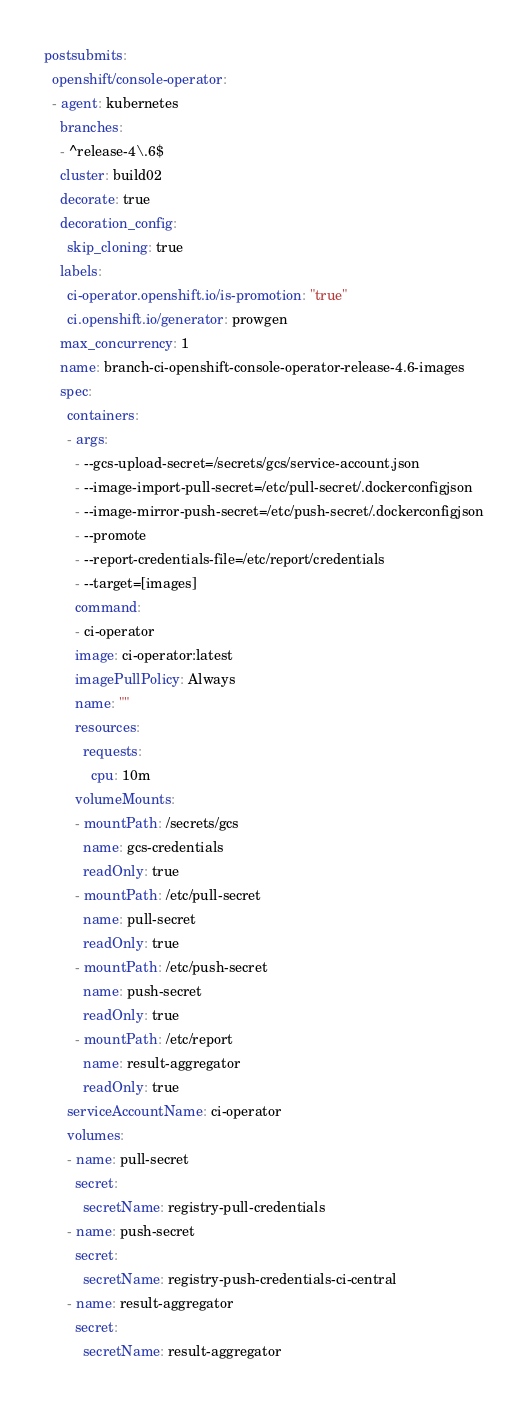<code> <loc_0><loc_0><loc_500><loc_500><_YAML_>postsubmits:
  openshift/console-operator:
  - agent: kubernetes
    branches:
    - ^release-4\.6$
    cluster: build02
    decorate: true
    decoration_config:
      skip_cloning: true
    labels:
      ci-operator.openshift.io/is-promotion: "true"
      ci.openshift.io/generator: prowgen
    max_concurrency: 1
    name: branch-ci-openshift-console-operator-release-4.6-images
    spec:
      containers:
      - args:
        - --gcs-upload-secret=/secrets/gcs/service-account.json
        - --image-import-pull-secret=/etc/pull-secret/.dockerconfigjson
        - --image-mirror-push-secret=/etc/push-secret/.dockerconfigjson
        - --promote
        - --report-credentials-file=/etc/report/credentials
        - --target=[images]
        command:
        - ci-operator
        image: ci-operator:latest
        imagePullPolicy: Always
        name: ""
        resources:
          requests:
            cpu: 10m
        volumeMounts:
        - mountPath: /secrets/gcs
          name: gcs-credentials
          readOnly: true
        - mountPath: /etc/pull-secret
          name: pull-secret
          readOnly: true
        - mountPath: /etc/push-secret
          name: push-secret
          readOnly: true
        - mountPath: /etc/report
          name: result-aggregator
          readOnly: true
      serviceAccountName: ci-operator
      volumes:
      - name: pull-secret
        secret:
          secretName: registry-pull-credentials
      - name: push-secret
        secret:
          secretName: registry-push-credentials-ci-central
      - name: result-aggregator
        secret:
          secretName: result-aggregator
</code> 